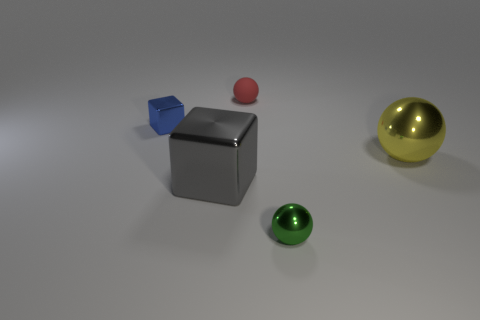Subtract all tiny balls. How many balls are left? 1 Add 2 small cyan metal balls. How many objects exist? 7 Subtract all purple balls. Subtract all blue cubes. How many balls are left? 3 Add 4 balls. How many balls exist? 7 Subtract 0 gray spheres. How many objects are left? 5 Subtract all spheres. How many objects are left? 2 Subtract all large yellow objects. Subtract all cyan rubber objects. How many objects are left? 4 Add 2 tiny matte balls. How many tiny matte balls are left? 3 